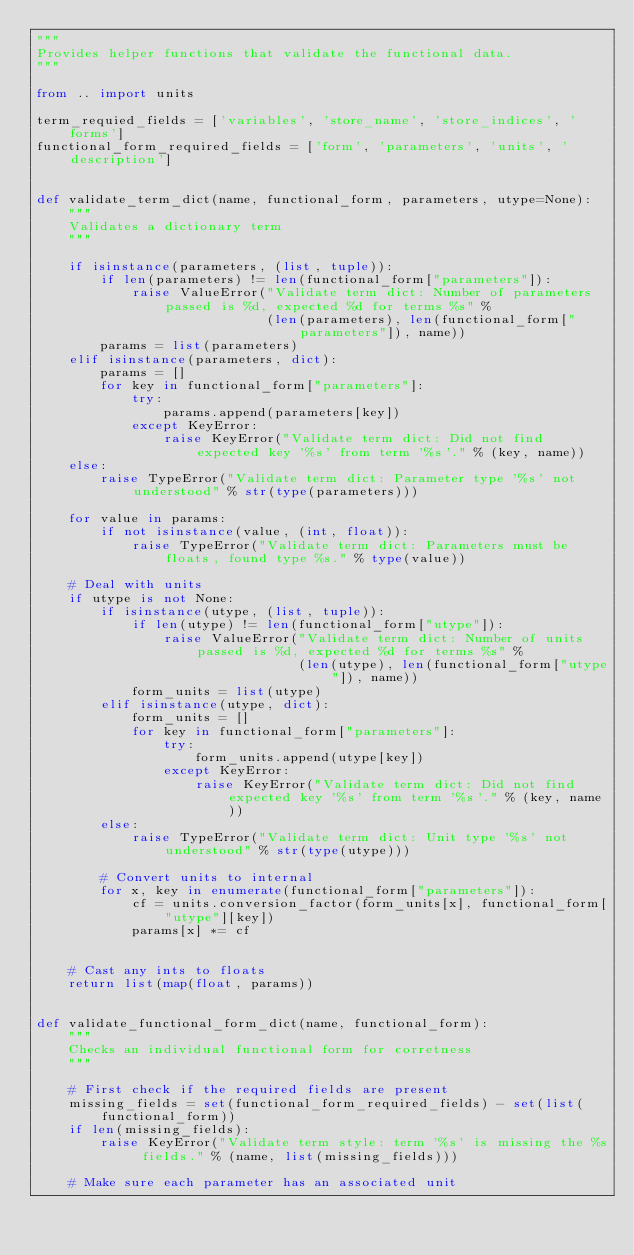Convert code to text. <code><loc_0><loc_0><loc_500><loc_500><_Python_>"""
Provides helper functions that validate the functional data.
"""

from .. import units

term_requied_fields = ['variables', 'store_name', 'store_indices', 'forms']
functional_form_required_fields = ['form', 'parameters', 'units', 'description']


def validate_term_dict(name, functional_form, parameters, utype=None):
    """
    Validates a dictionary term
    """

    if isinstance(parameters, (list, tuple)):
        if len(parameters) != len(functional_form["parameters"]):
            raise ValueError("Validate term dict: Number of parameters passed is %d, expected %d for terms %s" %
                             (len(parameters), len(functional_form["parameters"]), name))
        params = list(parameters)
    elif isinstance(parameters, dict):
        params = []
        for key in functional_form["parameters"]:
            try:
                params.append(parameters[key])
            except KeyError:
                raise KeyError("Validate term dict: Did not find expected key '%s' from term '%s'." % (key, name))
    else:
        raise TypeError("Validate term dict: Parameter type '%s' not understood" % str(type(parameters)))

    for value in params:
        if not isinstance(value, (int, float)):
            raise TypeError("Validate term dict: Parameters must be floats, found type %s." % type(value))

    # Deal with units
    if utype is not None:
        if isinstance(utype, (list, tuple)):
            if len(utype) != len(functional_form["utype"]):
                raise ValueError("Validate term dict: Number of units passed is %d, expected %d for terms %s" %
                                 (len(utype), len(functional_form["utype"]), name))
            form_units = list(utype)
        elif isinstance(utype, dict):
            form_units = []
            for key in functional_form["parameters"]:
                try:
                    form_units.append(utype[key])
                except KeyError:
                    raise KeyError("Validate term dict: Did not find expected key '%s' from term '%s'." % (key, name))
        else:
            raise TypeError("Validate term dict: Unit type '%s' not understood" % str(type(utype)))

        # Convert units to internal
        for x, key in enumerate(functional_form["parameters"]):
            cf = units.conversion_factor(form_units[x], functional_form["utype"][key])
            params[x] *= cf


    # Cast any ints to floats
    return list(map(float, params))


def validate_functional_form_dict(name, functional_form):
    """
    Checks an individual functional form for corretness
    """

    # First check if the required fields are present
    missing_fields = set(functional_form_required_fields) - set(list(functional_form))
    if len(missing_fields):
        raise KeyError("Validate term style: term '%s' is missing the %s fields." % (name, list(missing_fields)))

    # Make sure each parameter has an associated unit</code> 